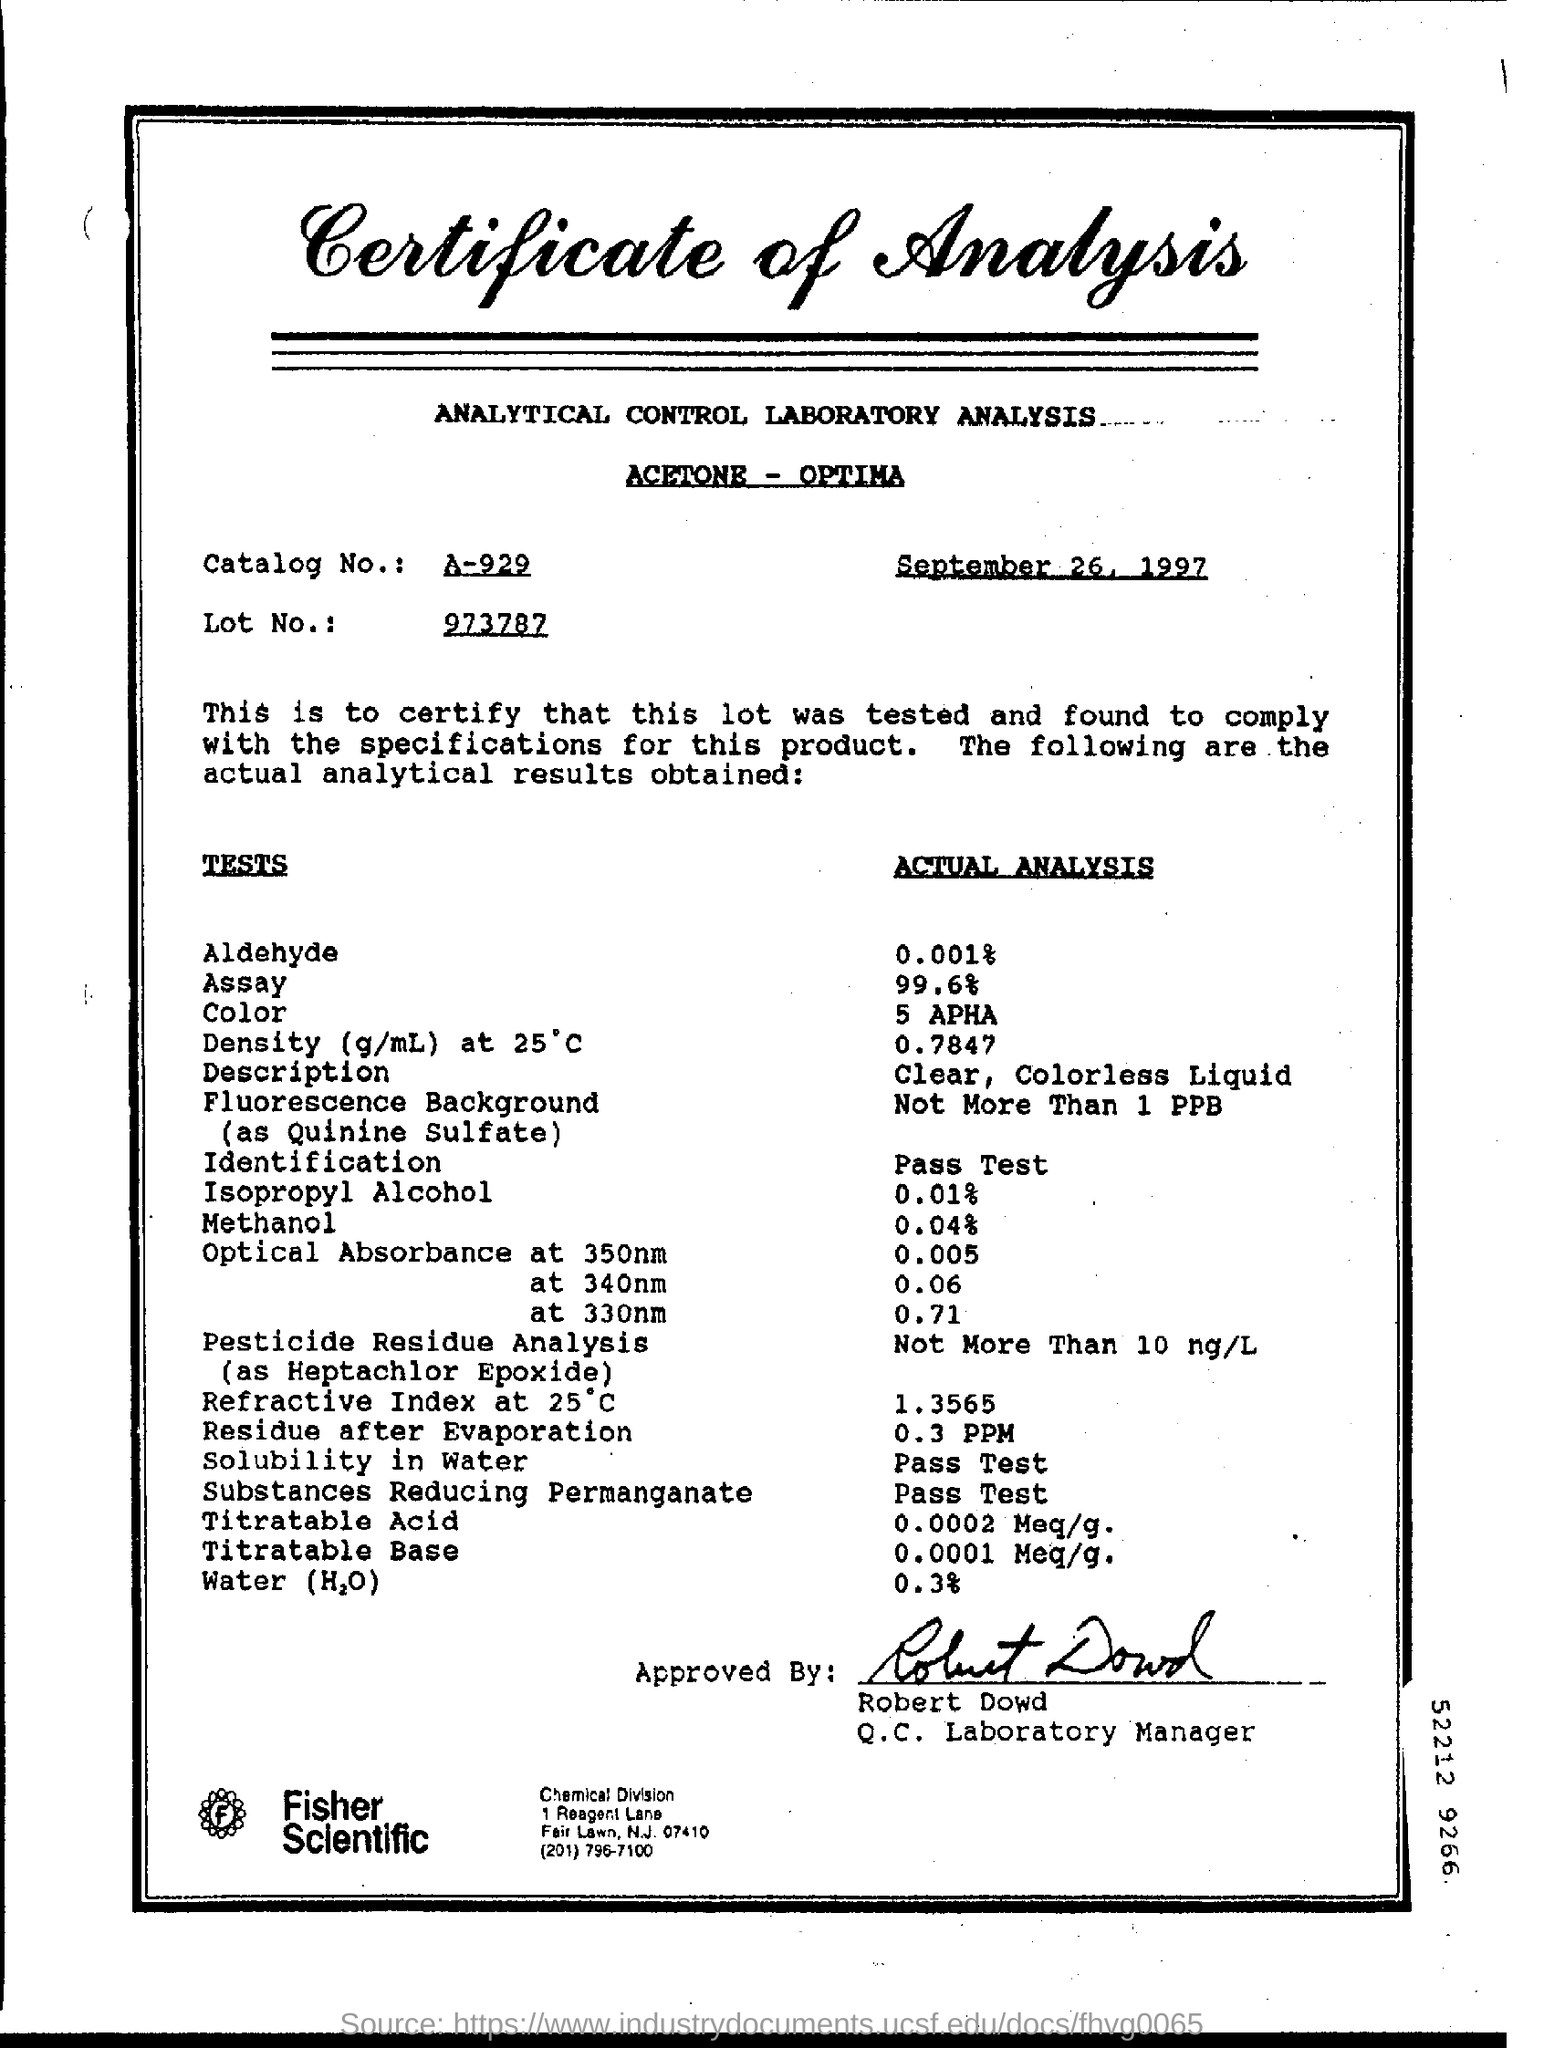What is written in the Letter Head ?
Provide a succinct answer. Certificate of analysis. What is the Catalog Number ?
Offer a terse response. A-929. What is the date mentioned in the top of the document ?
Your answer should be very brief. September 26, 1997. What is the Actual Analysis of Color ?
Your answer should be compact. 5 APHA. Who is the Q.C. Laboratory Manager ?
Keep it short and to the point. Robert Dowd. What is the Description of Actual Analysis ?
Provide a succinct answer. Clear, colorless liquid. 